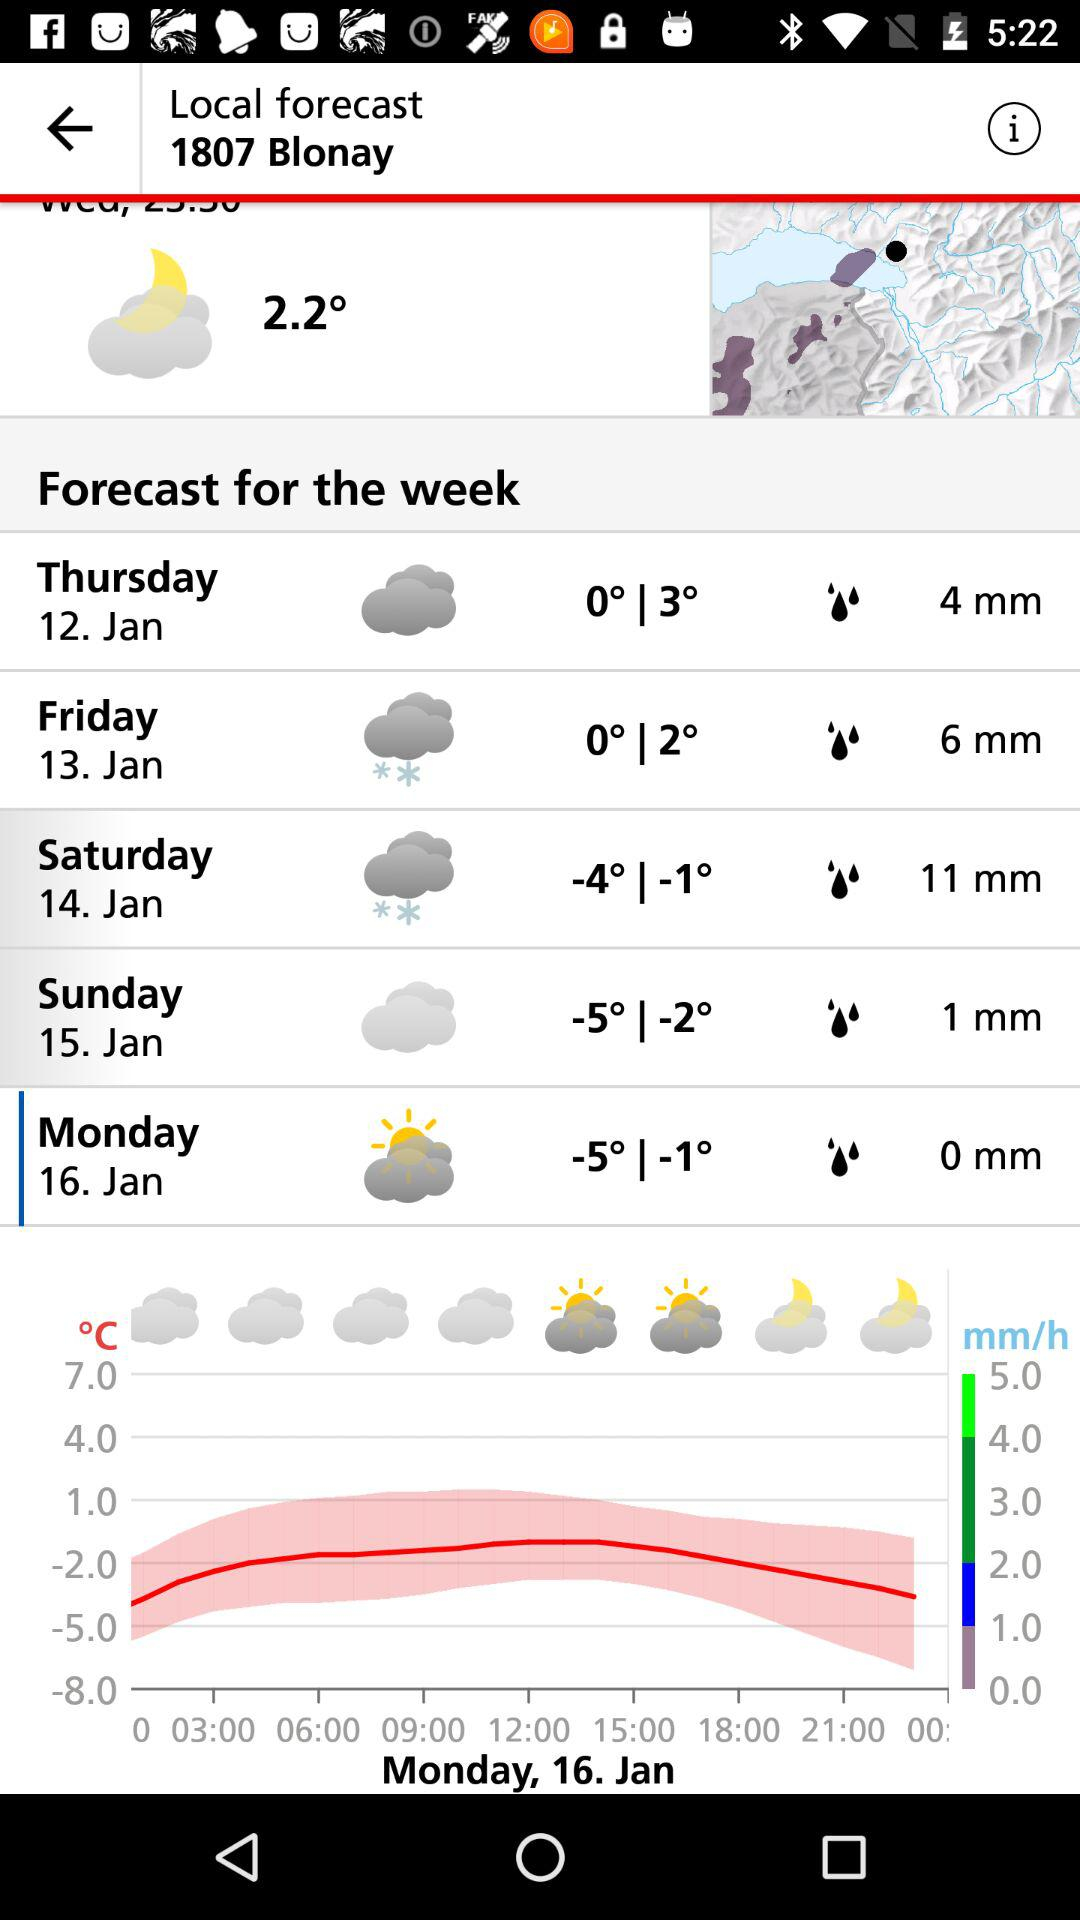For what date is the weather forecast chart being shown? Monday, 16. Jan is being shown. 